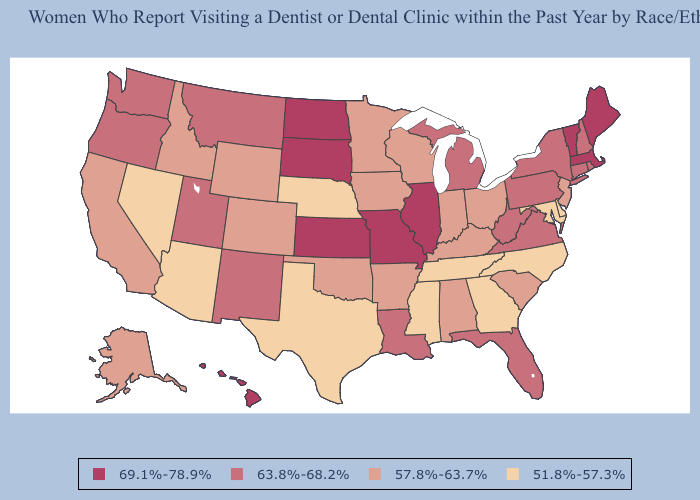How many symbols are there in the legend?
Keep it brief. 4. Does Minnesota have a lower value than Louisiana?
Answer briefly. Yes. What is the value of Kentucky?
Short answer required. 57.8%-63.7%. Does Alabama have the highest value in the USA?
Give a very brief answer. No. Which states have the lowest value in the West?
Keep it brief. Arizona, Nevada. What is the value of North Carolina?
Write a very short answer. 51.8%-57.3%. Does New York have the highest value in the Northeast?
Answer briefly. No. Name the states that have a value in the range 57.8%-63.7%?
Write a very short answer. Alabama, Alaska, Arkansas, California, Colorado, Idaho, Indiana, Iowa, Kentucky, Minnesota, New Jersey, Ohio, Oklahoma, South Carolina, Wisconsin, Wyoming. What is the value of Iowa?
Quick response, please. 57.8%-63.7%. Which states have the lowest value in the USA?
Keep it brief. Arizona, Delaware, Georgia, Maryland, Mississippi, Nebraska, Nevada, North Carolina, Tennessee, Texas. Which states have the lowest value in the Northeast?
Give a very brief answer. New Jersey. What is the highest value in states that border Connecticut?
Write a very short answer. 69.1%-78.9%. Does Iowa have the highest value in the USA?
Give a very brief answer. No. Name the states that have a value in the range 51.8%-57.3%?
Write a very short answer. Arizona, Delaware, Georgia, Maryland, Mississippi, Nebraska, Nevada, North Carolina, Tennessee, Texas. 